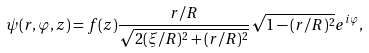Convert formula to latex. <formula><loc_0><loc_0><loc_500><loc_500>\psi ( r , \varphi , z ) = f ( z ) \frac { r / R } { \sqrt { 2 ( \xi / R ) ^ { 2 } + ( r / R ) ^ { 2 } } } \sqrt { 1 - ( r / R ) ^ { 2 } } e ^ { i \varphi } ,</formula> 